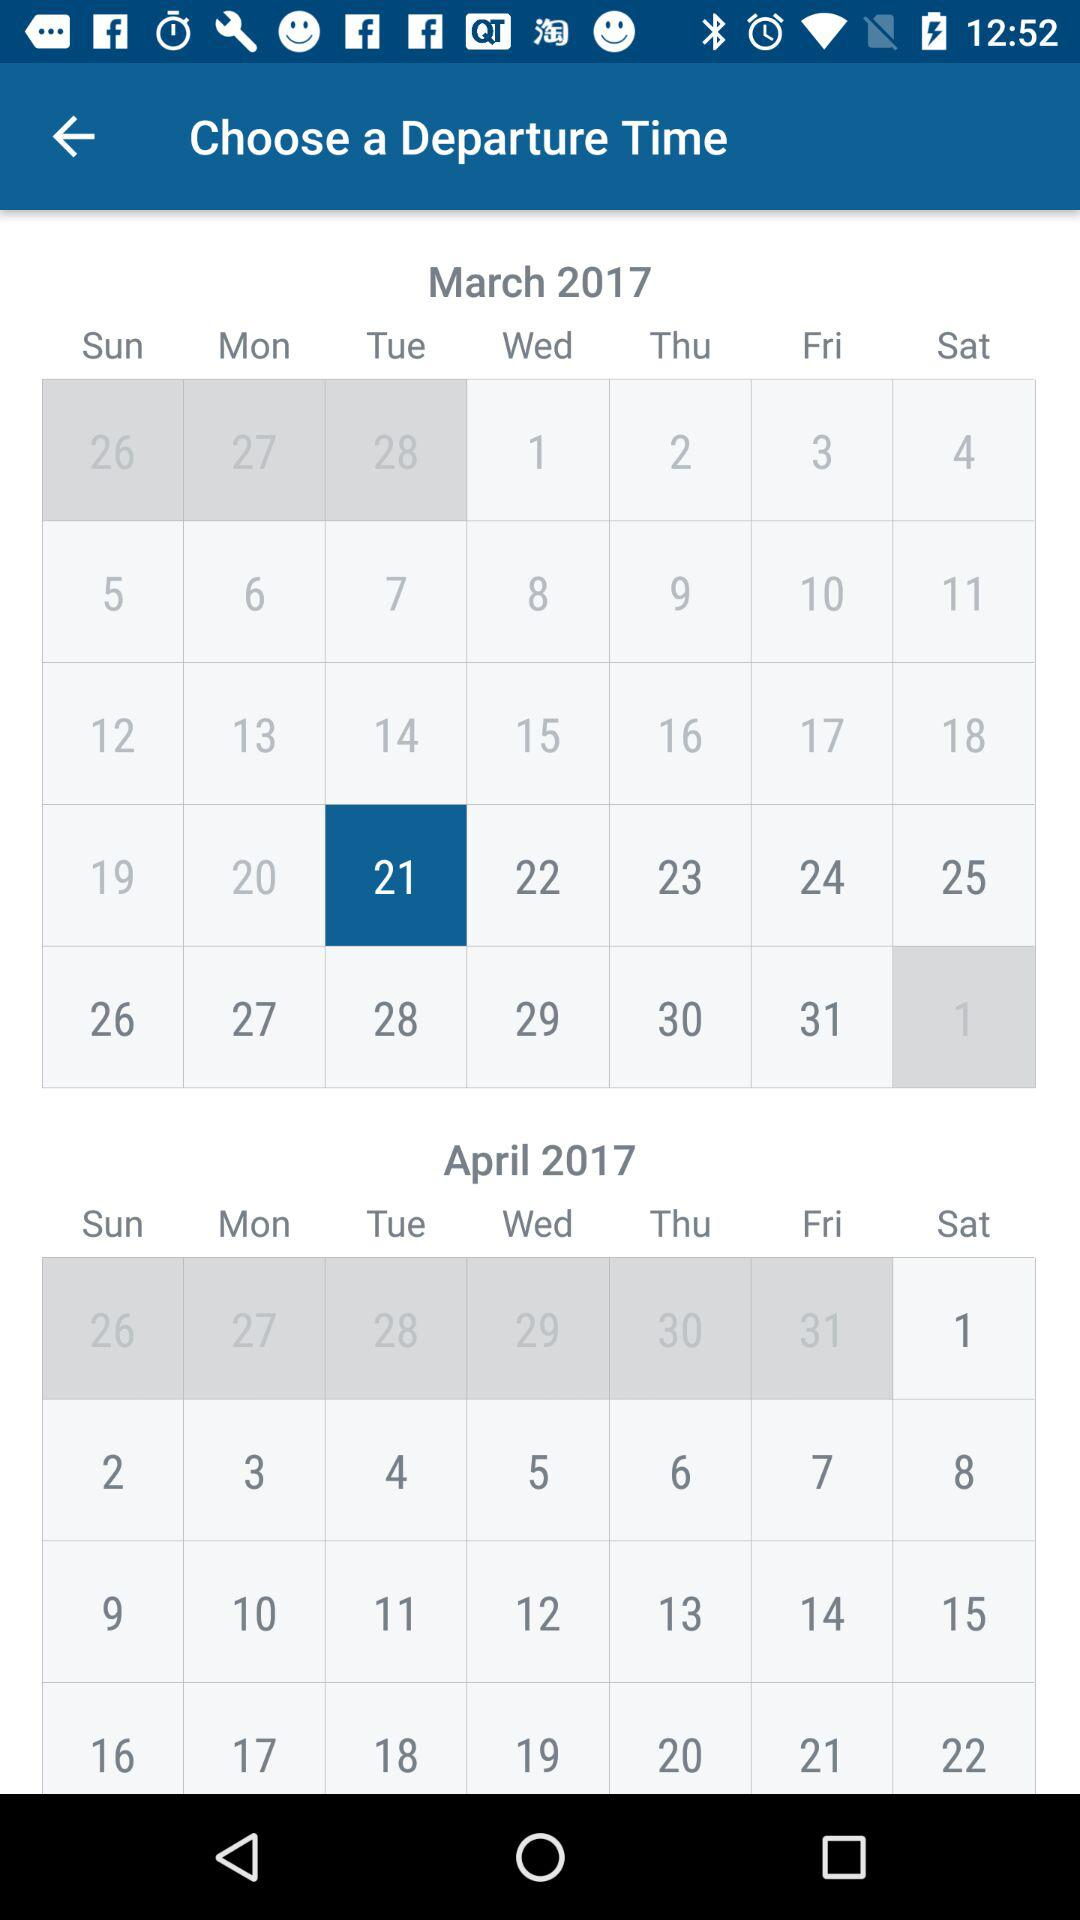What's the selected date? The selected date is Tuesday, March 21, 2017. 